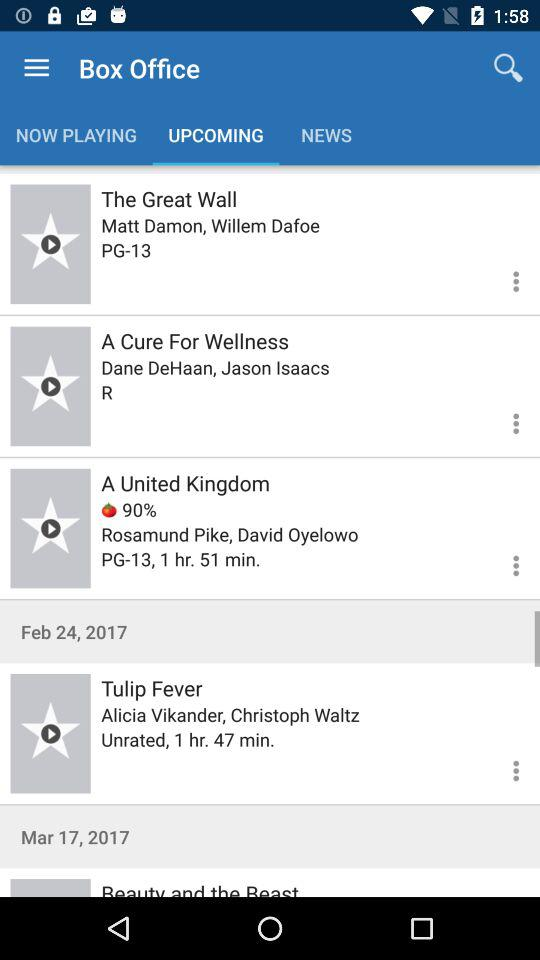How many movies are rated PG-13?
Answer the question using a single word or phrase. 2 